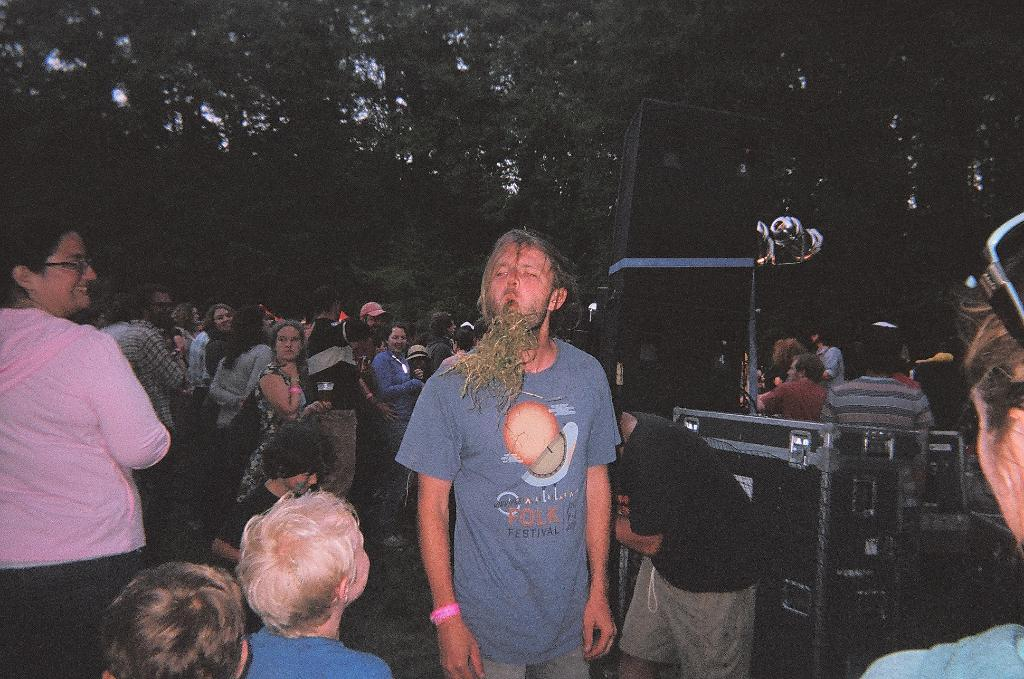What can be observed about the people in the image? There are people standing in the image. Can you describe any specific clothing or accessories worn by the people? Some of the people are wearing caps. What type of natural environment is visible in the image? There are trees visible in the image. What objects are present that might be related to sound or music? There are sound boxes present in the image. How many sheep can be seen grazing in the image? There are no sheep present in the image. What type of pipe is being used by the people in the image? There is no pipe visible in the image. 